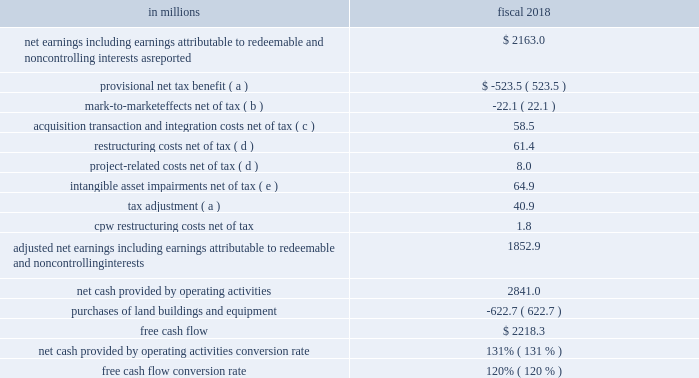Free cash flow conversion rate and total cash returned to shareholders as a percentage of free cash we believe these measures provide useful information to investors because they are important for assessing our efficiency in converting earnings to cash and returning cash to shareholders .
The calculation of free cash flow conversion rate and net cash provided by operating activities conversion rate , its equivalent gaap measure , follows: .
( a ) see note 14 to the consolidated financial statements in item 8 of this report .
( b ) see note 7 to the consolidated financial statements in item 8 of this report .
( c ) see note 3 to the consolidated financial statements in item 8 of this report .
( d ) see note 4 to the consolidated financial statements in item 8 of this report .
( e ) see note 6 to the consolidated financial statements in item 8 of this report .
See our reconciliation below of the effective income tax rate as reported to the effective income tax rate excluding certain items affecting comparability for the tax impact of each item affecting comparability. .
In 2018 what was the ratio of the net earnings to the net cash provided by operating activities? 
Computations: (2163.0 / 2841.0)
Answer: 0.76135. 